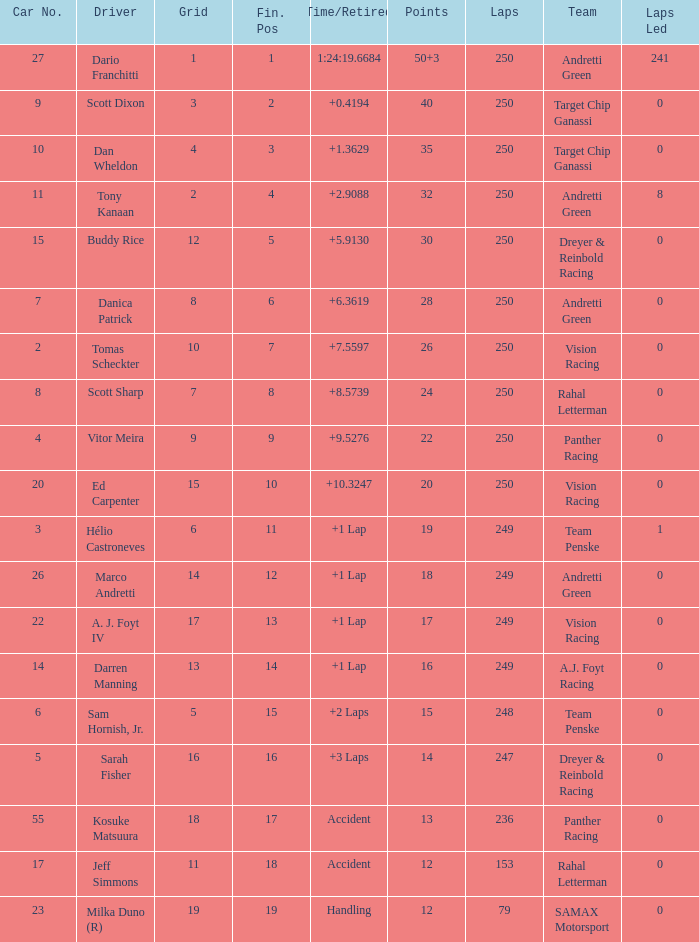Name the number of driver for fin pos of 19 1.0. 